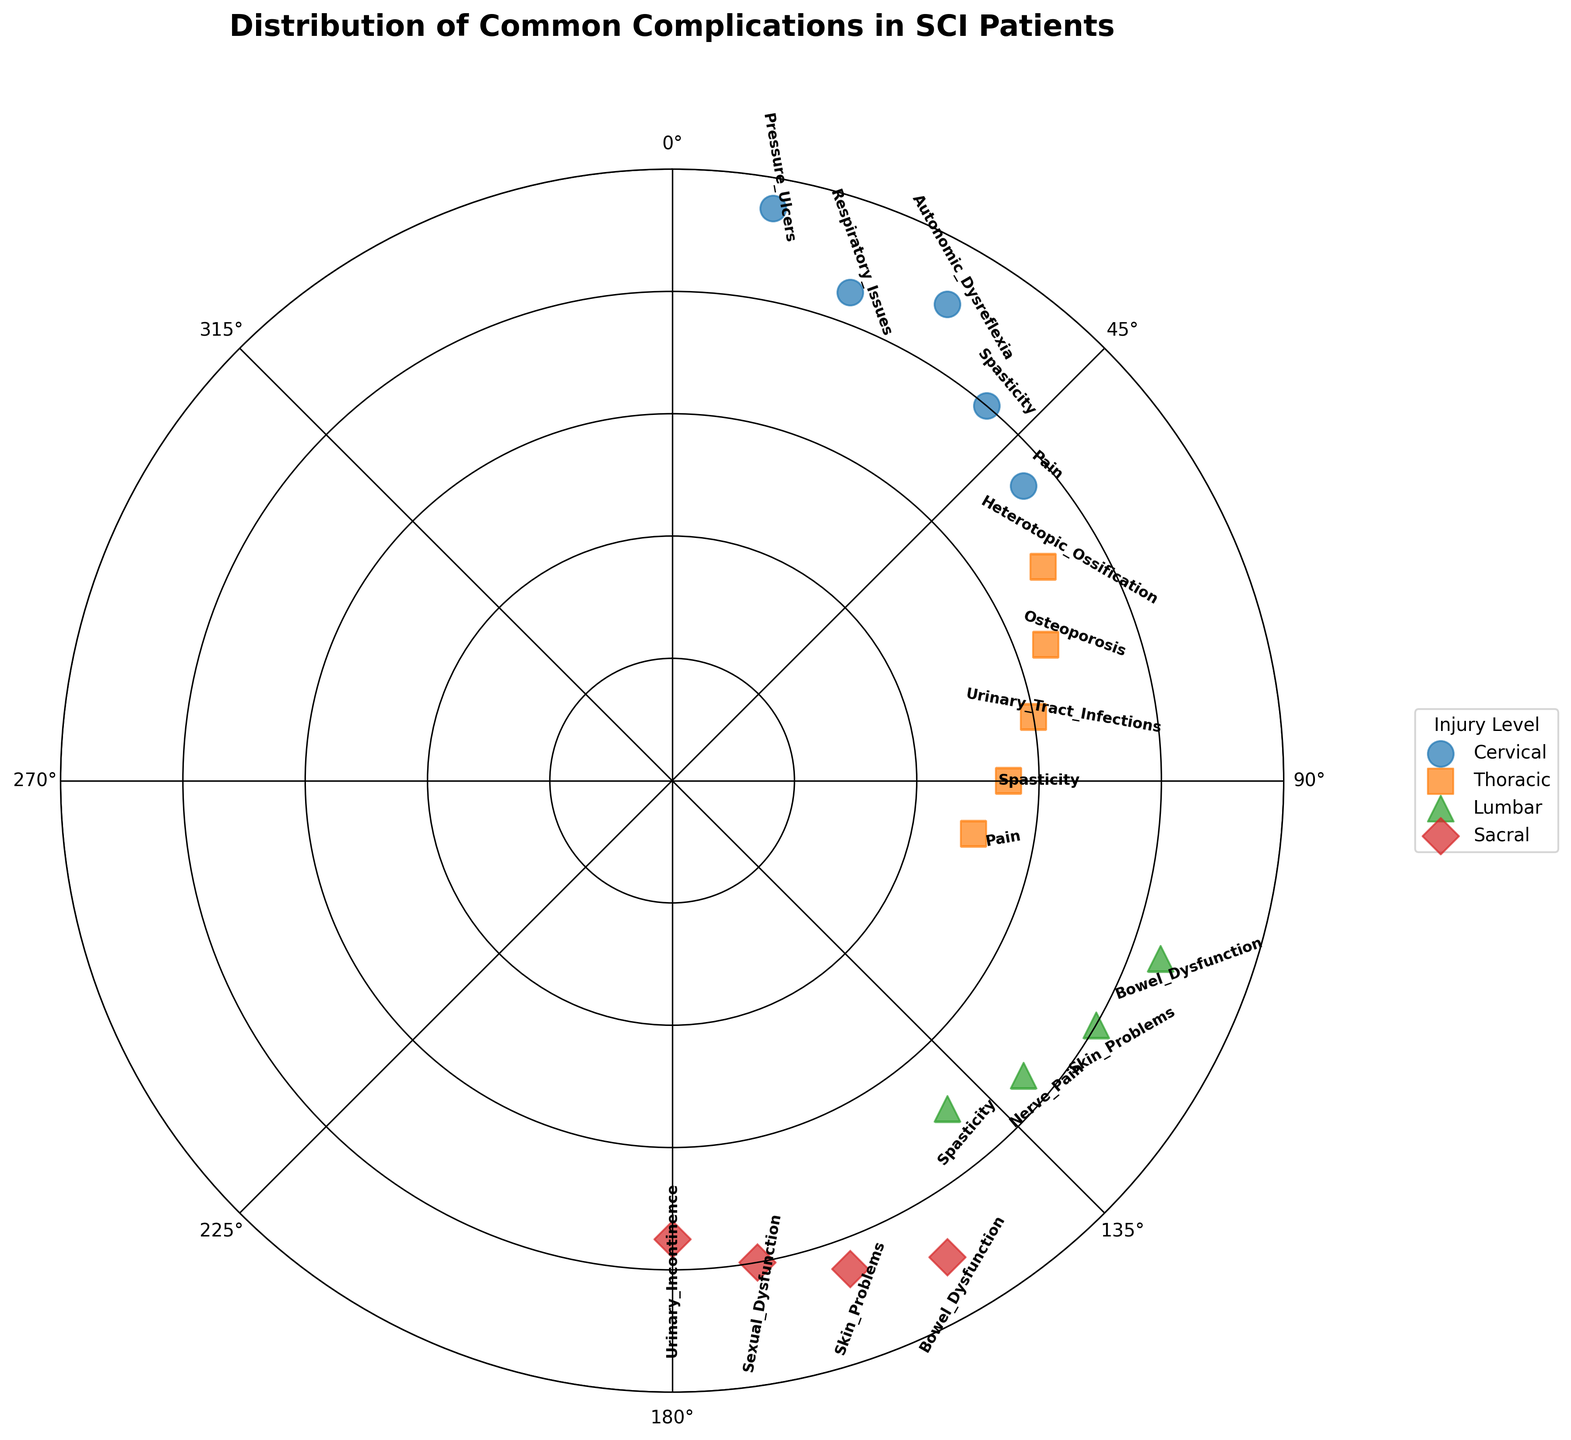What is the title of the figure? The title of the figure is usually displayed at the top of the plot. In this case, it can be found in bold and bigger font size compared to other text elements on the chart.
Answer: Distribution of Common Complications in SCI Patients Which injury level has the most complications listed in the chart? To determine the injury level with the most complications, you need to count the occurrences of each injury level. Cervical has 5, Thoracic has 5, Lumbar has 4, and Sacral has 4.
Answer: Cervical What is the radius value for Urinary Tract Infections in Thoracic injury level? First identify the Urinary Tract Infections data point, which is labeled on the chart within the Thoracic group. It is plotted with a radius value of 60.
Answer: 60 Which complication is the most distant (highest radius) for the Cervical injury level? Look for data points within the Cervical category (identify by color/marker). The one with the highest radius has the longest distance from the center. For Cervical, it's Pressure Ulcers at 95.
Answer: Pressure Ulcers Are there any complications that appear in more than one injury level? Check the labels for each complication and see if any names repeat across different injury levels. Spasticity and Bowel Dysfunction appear more than once.
Answer: Yes, Spasticity and Bowel Dysfunction Which injury level has a data point at the lowest radius value? Compare all the radius values for each injury level. The lowest radius value is 50, which corresponds to Pain in the Thoracic injury level.
Answer: Thoracic What is the average radius for complications in the Lumbar injury level? Sum the radius values for Lumbar and then divide by the number of complications. The radius values are 85, 80, 75, and 70, so the average is (85+80+75+70)/4 = 77.5.
Answer: 77.5 Which injury level has the complication with the largest angle value? Check the angle values associated with each injury level. The highest angle is 180, which corresponds to Urinary Incontinence in the Sacral injury level.
Answer: Sacral How many complications are represented with a radius greater than 80? Count the complications with radius values higher than 80. Pressure Ulcers, Respiratory Issues, Autonomic Dysreflexia, Bowel Dysfunction (Lumbar), Bowel Dysfunction (Sacral), and Skin Problems (Sacral) total to 6.
Answer: 6 